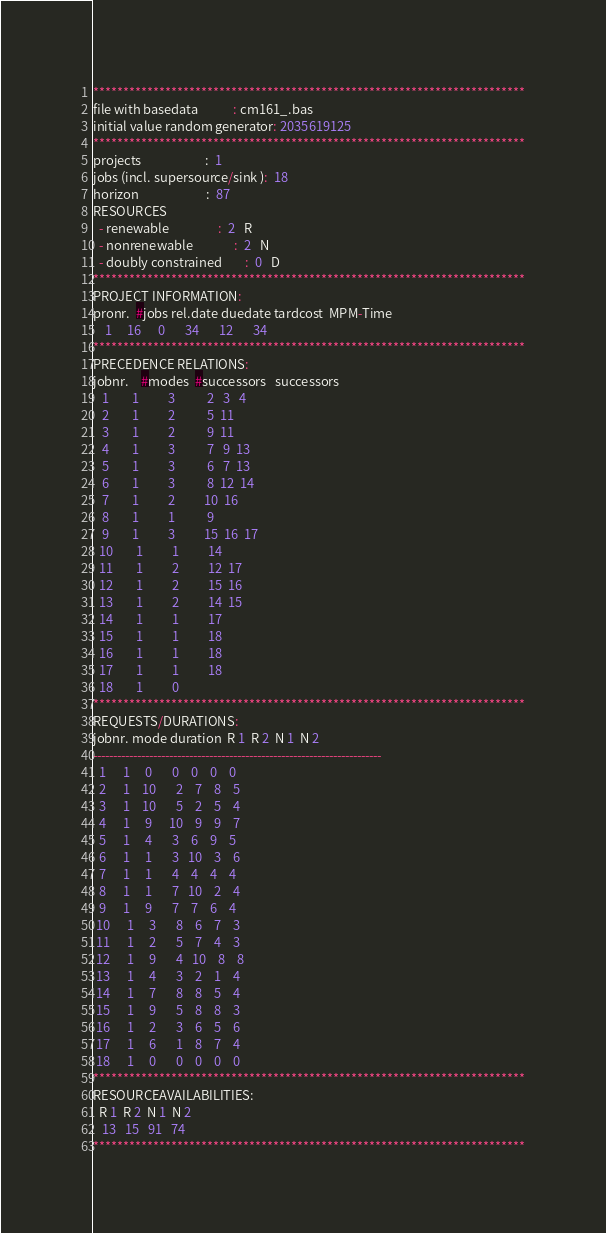Convert code to text. <code><loc_0><loc_0><loc_500><loc_500><_ObjectiveC_>************************************************************************
file with basedata            : cm161_.bas
initial value random generator: 2035619125
************************************************************************
projects                      :  1
jobs (incl. supersource/sink ):  18
horizon                       :  87
RESOURCES
  - renewable                 :  2   R
  - nonrenewable              :  2   N
  - doubly constrained        :  0   D
************************************************************************
PROJECT INFORMATION:
pronr.  #jobs rel.date duedate tardcost  MPM-Time
    1     16      0       34       12       34
************************************************************************
PRECEDENCE RELATIONS:
jobnr.    #modes  #successors   successors
   1        1          3           2   3   4
   2        1          2           5  11
   3        1          2           9  11
   4        1          3           7   9  13
   5        1          3           6   7  13
   6        1          3           8  12  14
   7        1          2          10  16
   8        1          1           9
   9        1          3          15  16  17
  10        1          1          14
  11        1          2          12  17
  12        1          2          15  16
  13        1          2          14  15
  14        1          1          17
  15        1          1          18
  16        1          1          18
  17        1          1          18
  18        1          0        
************************************************************************
REQUESTS/DURATIONS:
jobnr. mode duration  R 1  R 2  N 1  N 2
------------------------------------------------------------------------
  1      1     0       0    0    0    0
  2      1    10       2    7    8    5
  3      1    10       5    2    5    4
  4      1     9      10    9    9    7
  5      1     4       3    6    9    5
  6      1     1       3   10    3    6
  7      1     1       4    4    4    4
  8      1     1       7   10    2    4
  9      1     9       7    7    6    4
 10      1     3       8    6    7    3
 11      1     2       5    7    4    3
 12      1     9       4   10    8    8
 13      1     4       3    2    1    4
 14      1     7       8    8    5    4
 15      1     9       5    8    8    3
 16      1     2       3    6    5    6
 17      1     6       1    8    7    4
 18      1     0       0    0    0    0
************************************************************************
RESOURCEAVAILABILITIES:
  R 1  R 2  N 1  N 2
   13   15   91   74
************************************************************************
</code> 